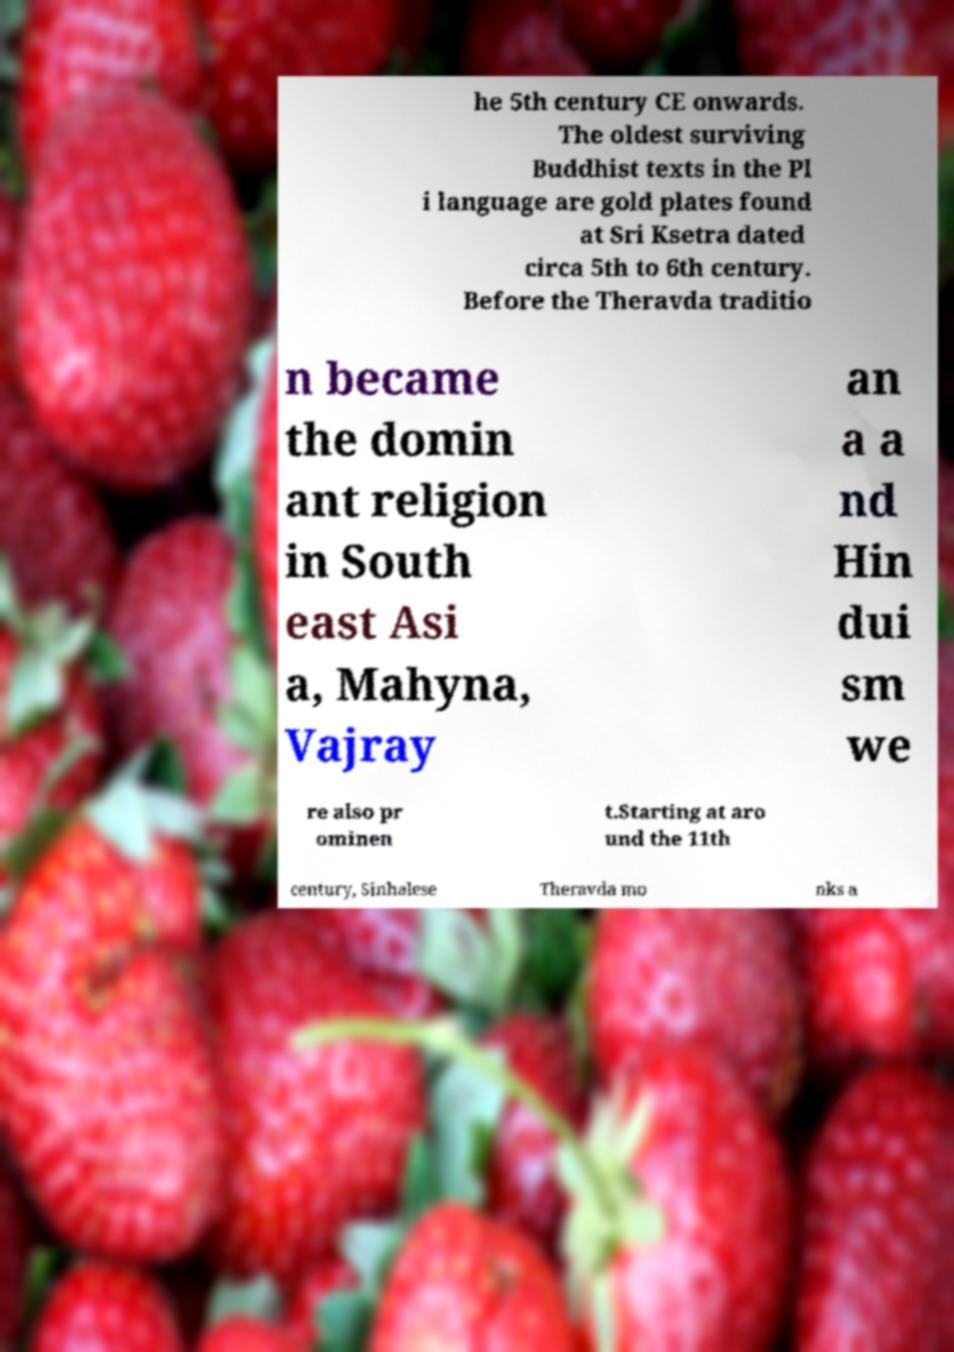Can you read and provide the text displayed in the image?This photo seems to have some interesting text. Can you extract and type it out for me? he 5th century CE onwards. The oldest surviving Buddhist texts in the Pl i language are gold plates found at Sri Ksetra dated circa 5th to 6th century. Before the Theravda traditio n became the domin ant religion in South east Asi a, Mahyna, Vajray an a a nd Hin dui sm we re also pr ominen t.Starting at aro und the 11th century, Sinhalese Theravda mo nks a 